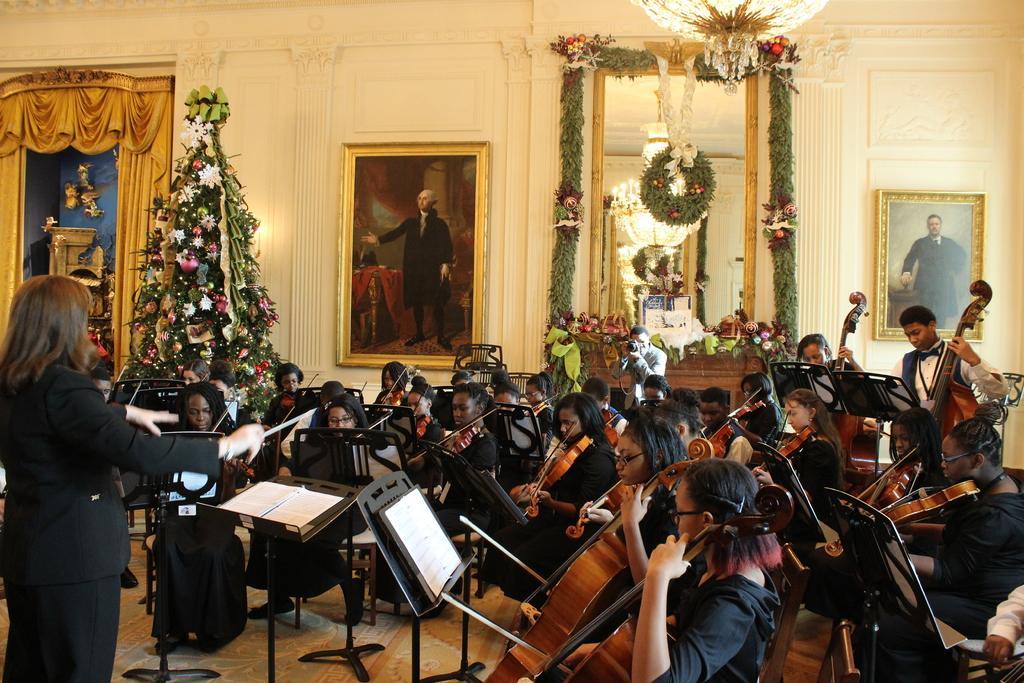Can you describe this image briefly? In the image we can see there are many people wearing clothes and they are sitting on the chair, and two of them are standing. These are books, stands and musical instruments. This is a floor, frame and a Christmas tree, there is even a mirror. 